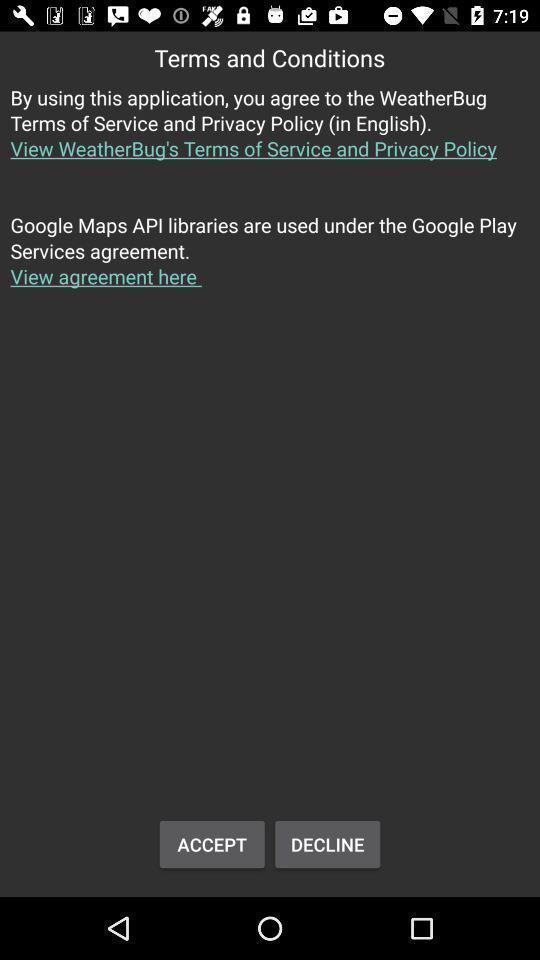Provide a detailed account of this screenshot. Terms and conditions of weather app. 